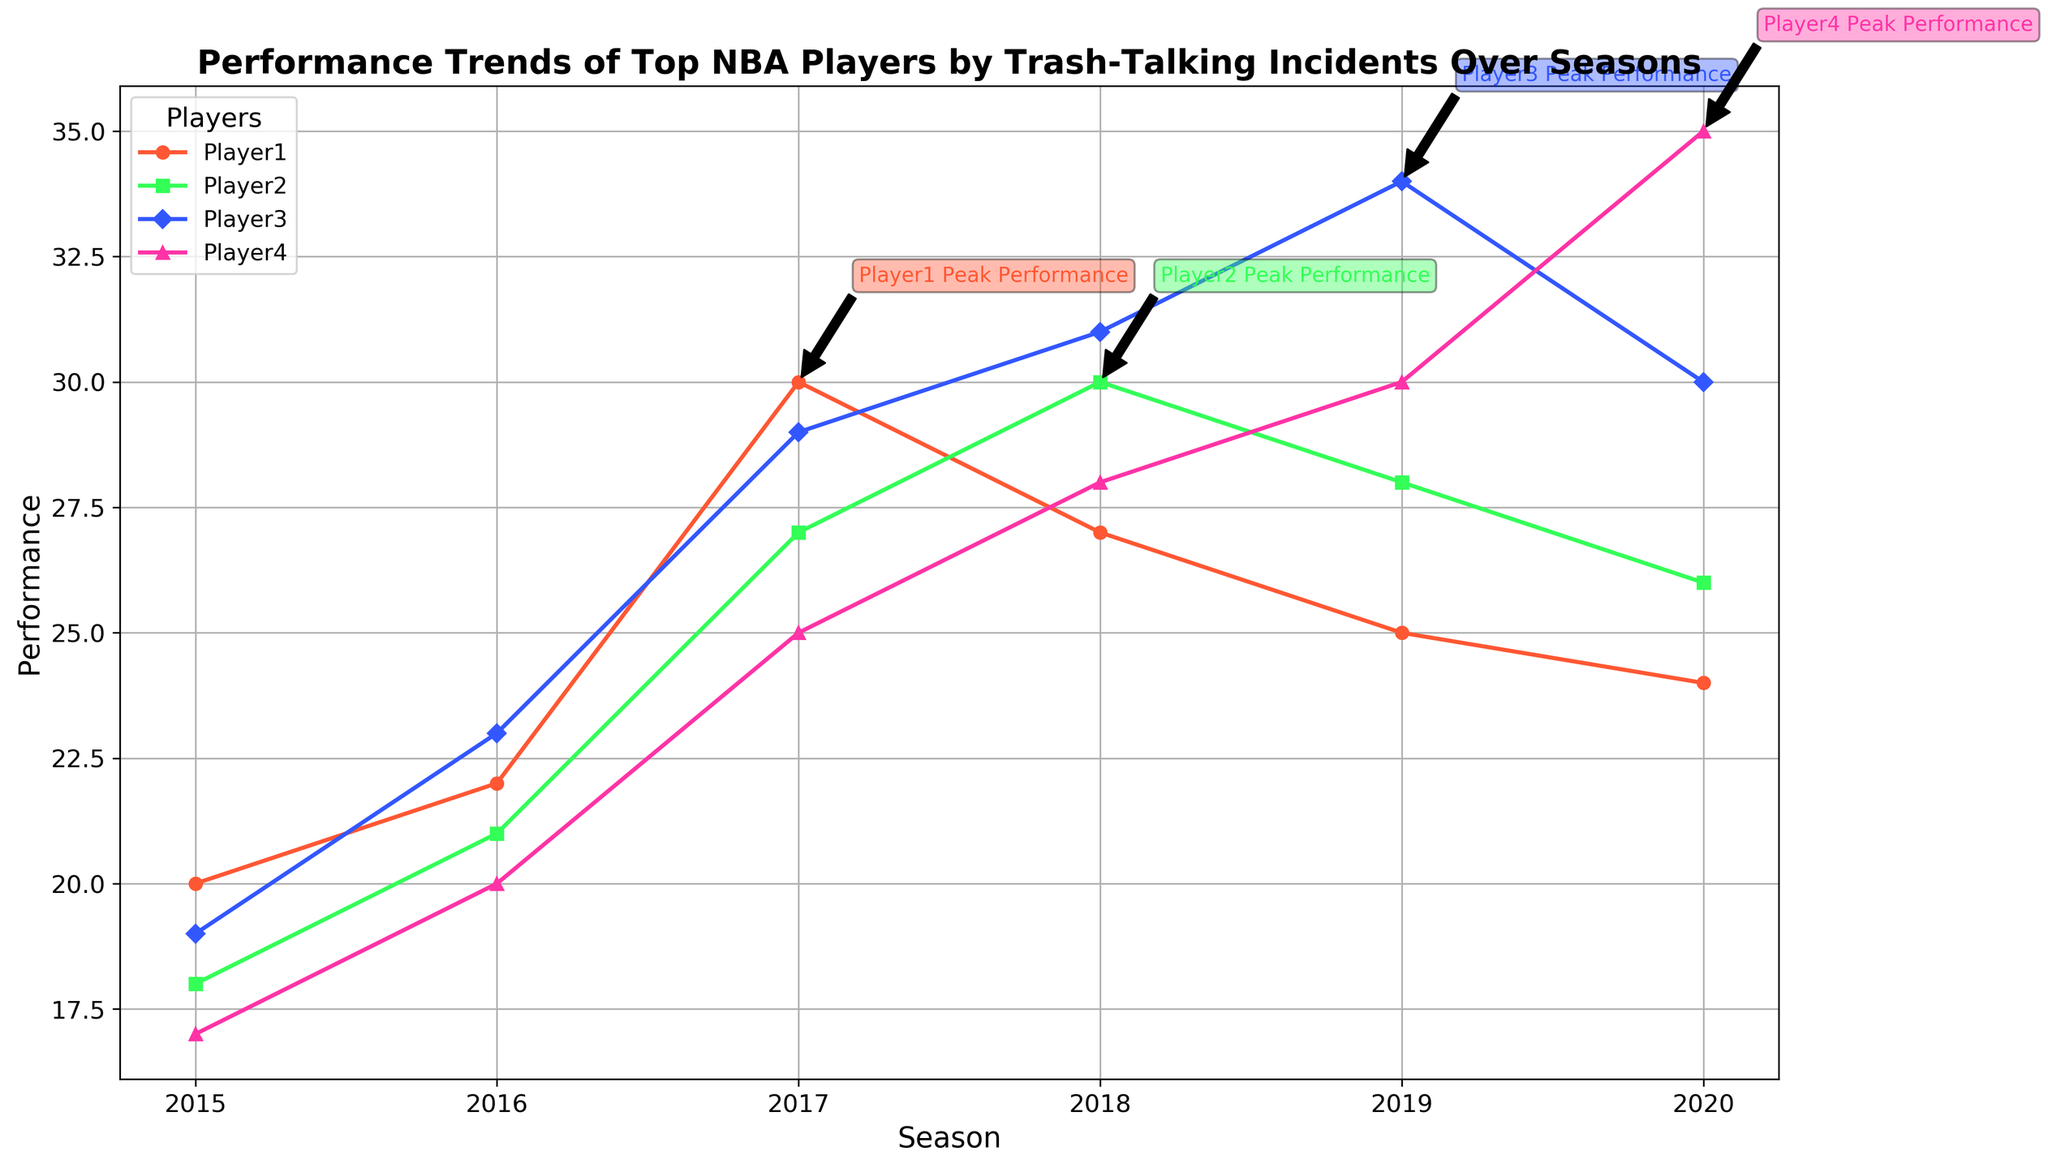What is the peak performance year for Player3? The annotation on the figure indicates that the peak performance year for Player3 is 2019. The annotation is placed near the data point for the 2019 season.
Answer: 2019 Which player had the highest performance in the 2020 season? By observing the plots, for the 2020 season, Player4's performance is the highest as it reaches 35, which is higher than the performance of other players for the same season.
Answer: Player4 How does Player4's trash-talking incidents trend compare to their performance trend over the seasons? The plot and the dataset show that both Player4's trash-talking incidents and performance increased over time, culminating in the peak year of 2020. Player4's trash-talking incidents rose consistently from 2015 to 2020, similar to their performance trend.
Answer: Both increased In which year did Player1 show a peak performance, and what was the performance value? According to the annotation and the peak data point on the plot, Player1's peak performance occurred in 2017, with a performance value of 30.
Answer: 2017, 30 Compare the performance of Player2 and Player3 in the year 2018. Which player performed better? Observing the plot for the year 2018, Player2’s performance is 30 while Player3’s is 31. Thus, Player3 performed slightly better than Player2 in 2018.
Answer: Player3 Which season had the highest combined performance from all players? We sum the performance values for each season. The highest sum is for 2020, with Player1 having 24, Player2 with 26, Player3 with 30, and Player4 with 35. Adding these gives a total of 115, which is higher than in any other season.
Answer: 2020 Calculate the difference in peak performance between Player1 and Player4. Player1's peak performance is 30 (in 2017) and Player4's is 35 (in 2020). The difference between these peak performances is 35 - 30 = 5.
Answer: 5 What’s the average performance increase per season for Player3 from 2015 to 2019? Player3’s performance increased from 19 in 2015 to 34 in 2019. Thus, the performance increase over the 4-year period (2019-2015) is 34 - 19 = 15. Dividing this by 4 gives an average increase of 15/4 = 3.75 per season.
Answer: 3.75 Which player had the most consistent performance trend over the seasons? By looking at the smoothness and the gradual increments in the plots, Player2 shows a more consistent performance trend from 2015 to 2020 compared to the other players, where the performance trend is more uniform.
Answer: Player2 Calculate the total number of trash-talking incidents for Player2 across all seasons. Summing up the trash-talking incidents for Player2: 6 (2015) + 11 (2016) + 16 (2017) + 21 (2018) + 19 (2019) + 13 (2020) = 86.
Answer: 86 